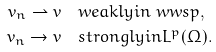Convert formula to latex. <formula><loc_0><loc_0><loc_500><loc_500>v _ { n } \rightharpoonup v & \quad w e a k l y i n \ w w s p , \\ v _ { n } \to v & \quad s t r o n g l y i n L ^ { p } ( \Omega ) . \\</formula> 